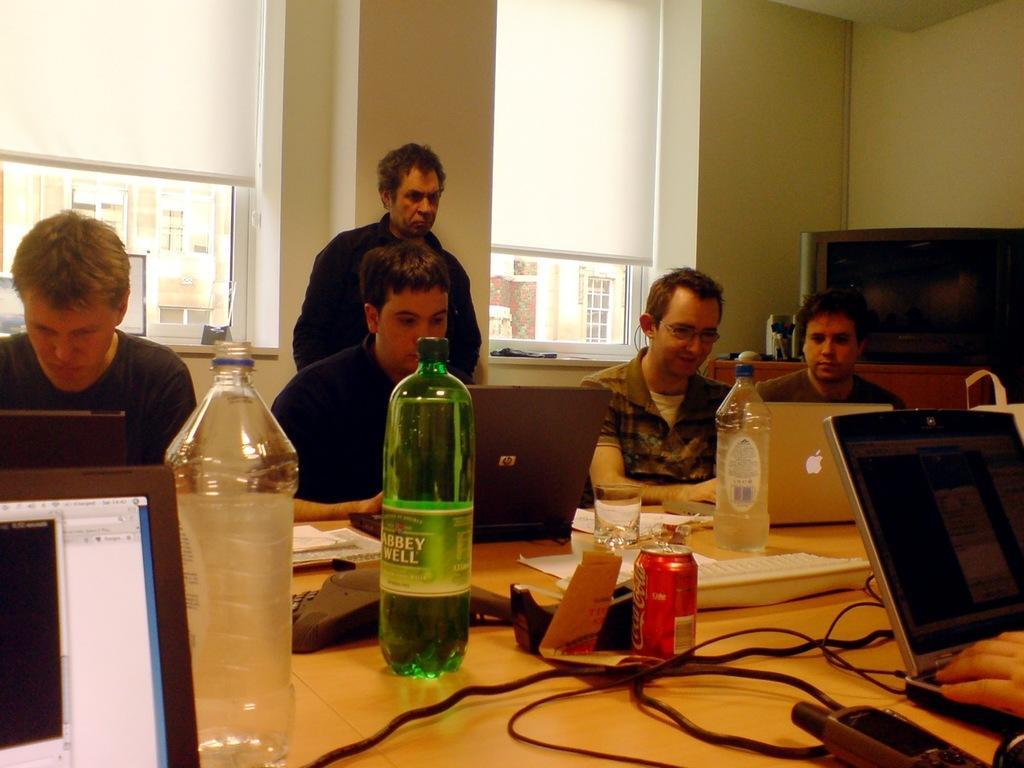Can you describe this image briefly? There are some people sitting in the chairs in front of a table on which laptops, water bottles, wires, coke tins and papers were placed. All of them were men. Behind them there is another guy standing. In the background there are some windows curtains and walls here. 